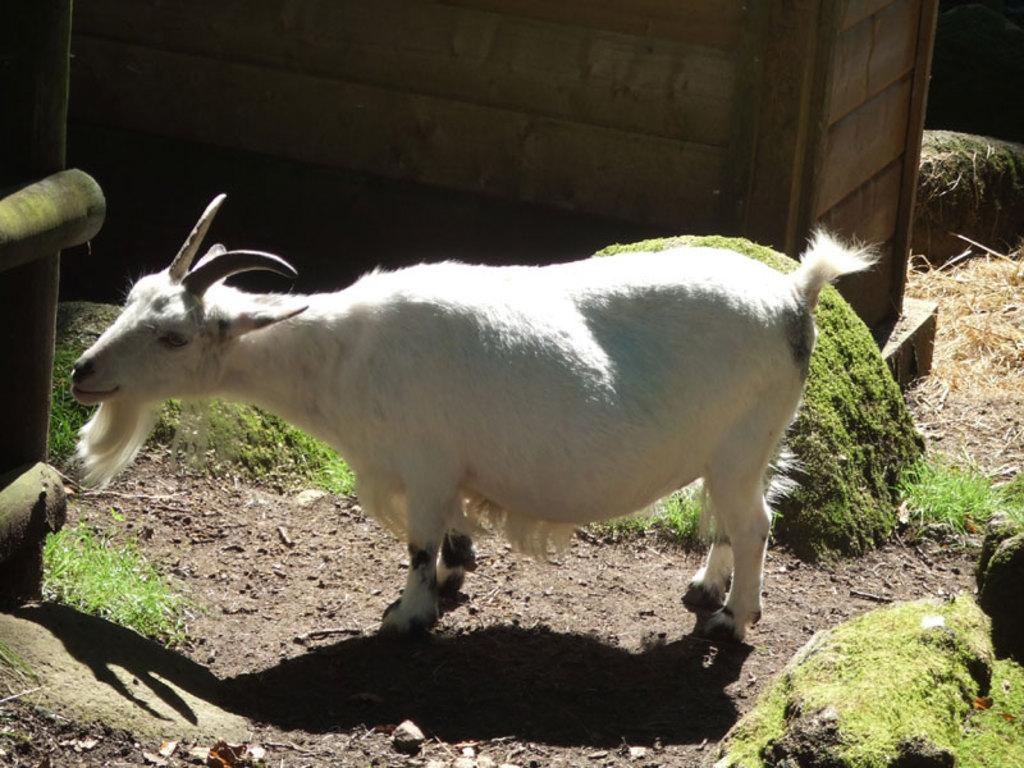What type of animal is in the image? There is a white goat in the image. Where is the goat located? The goat is on the ground. What type of vegetation is present in the image? There is grass in the image. What else can be seen on the ground in the image? There are small stones on the ground. What type of structure is visible in the image? There is no structure visible in the image; it primarily features a white goat, grass, and small stones. 